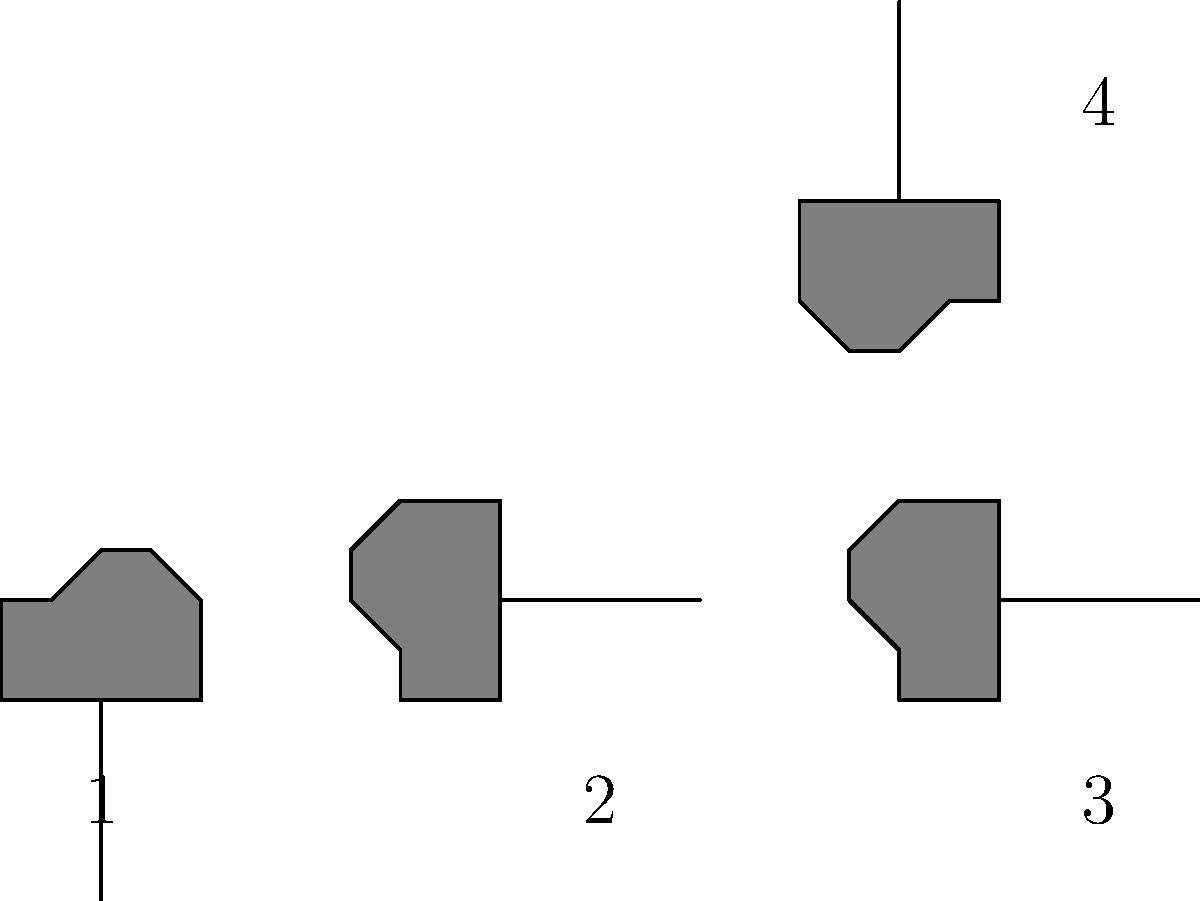Your grandchild is explaining the concept of transformations using their gaming mouse icon. The image shows the mouse icon at four different positions, labeled 1 through 4. Identify the sequence of transformations that moves the mouse icon from position 1 to position 4. Let's analyze the transformations step-by-step:

1. From position 1 to position 2:
   The mouse icon is rotated 90° clockwise and translated 50 units to the right.

2. From position 2 to position 3:
   The mouse icon is translated 50 units to the right. No rotation occurs here.

3. From position 3 to position 4:
   The mouse icon is rotated 90° clockwise and translated 50 units upward.

To summarize the complete sequence of transformations from position 1 to position 4:

a) Rotate 90° clockwise
b) Translate 50 units right
c) Translate 50 units right again (total 100 units right)
d) Rotate 90° clockwise again (total 180° rotation)
e) Translate 50 units up

This sequence can be simplified to:
1. Rotate 180° clockwise
2. Translate 100 units right
3. Translate 50 units up
Answer: Rotate 180°, translate 100 units right, translate 50 units up 